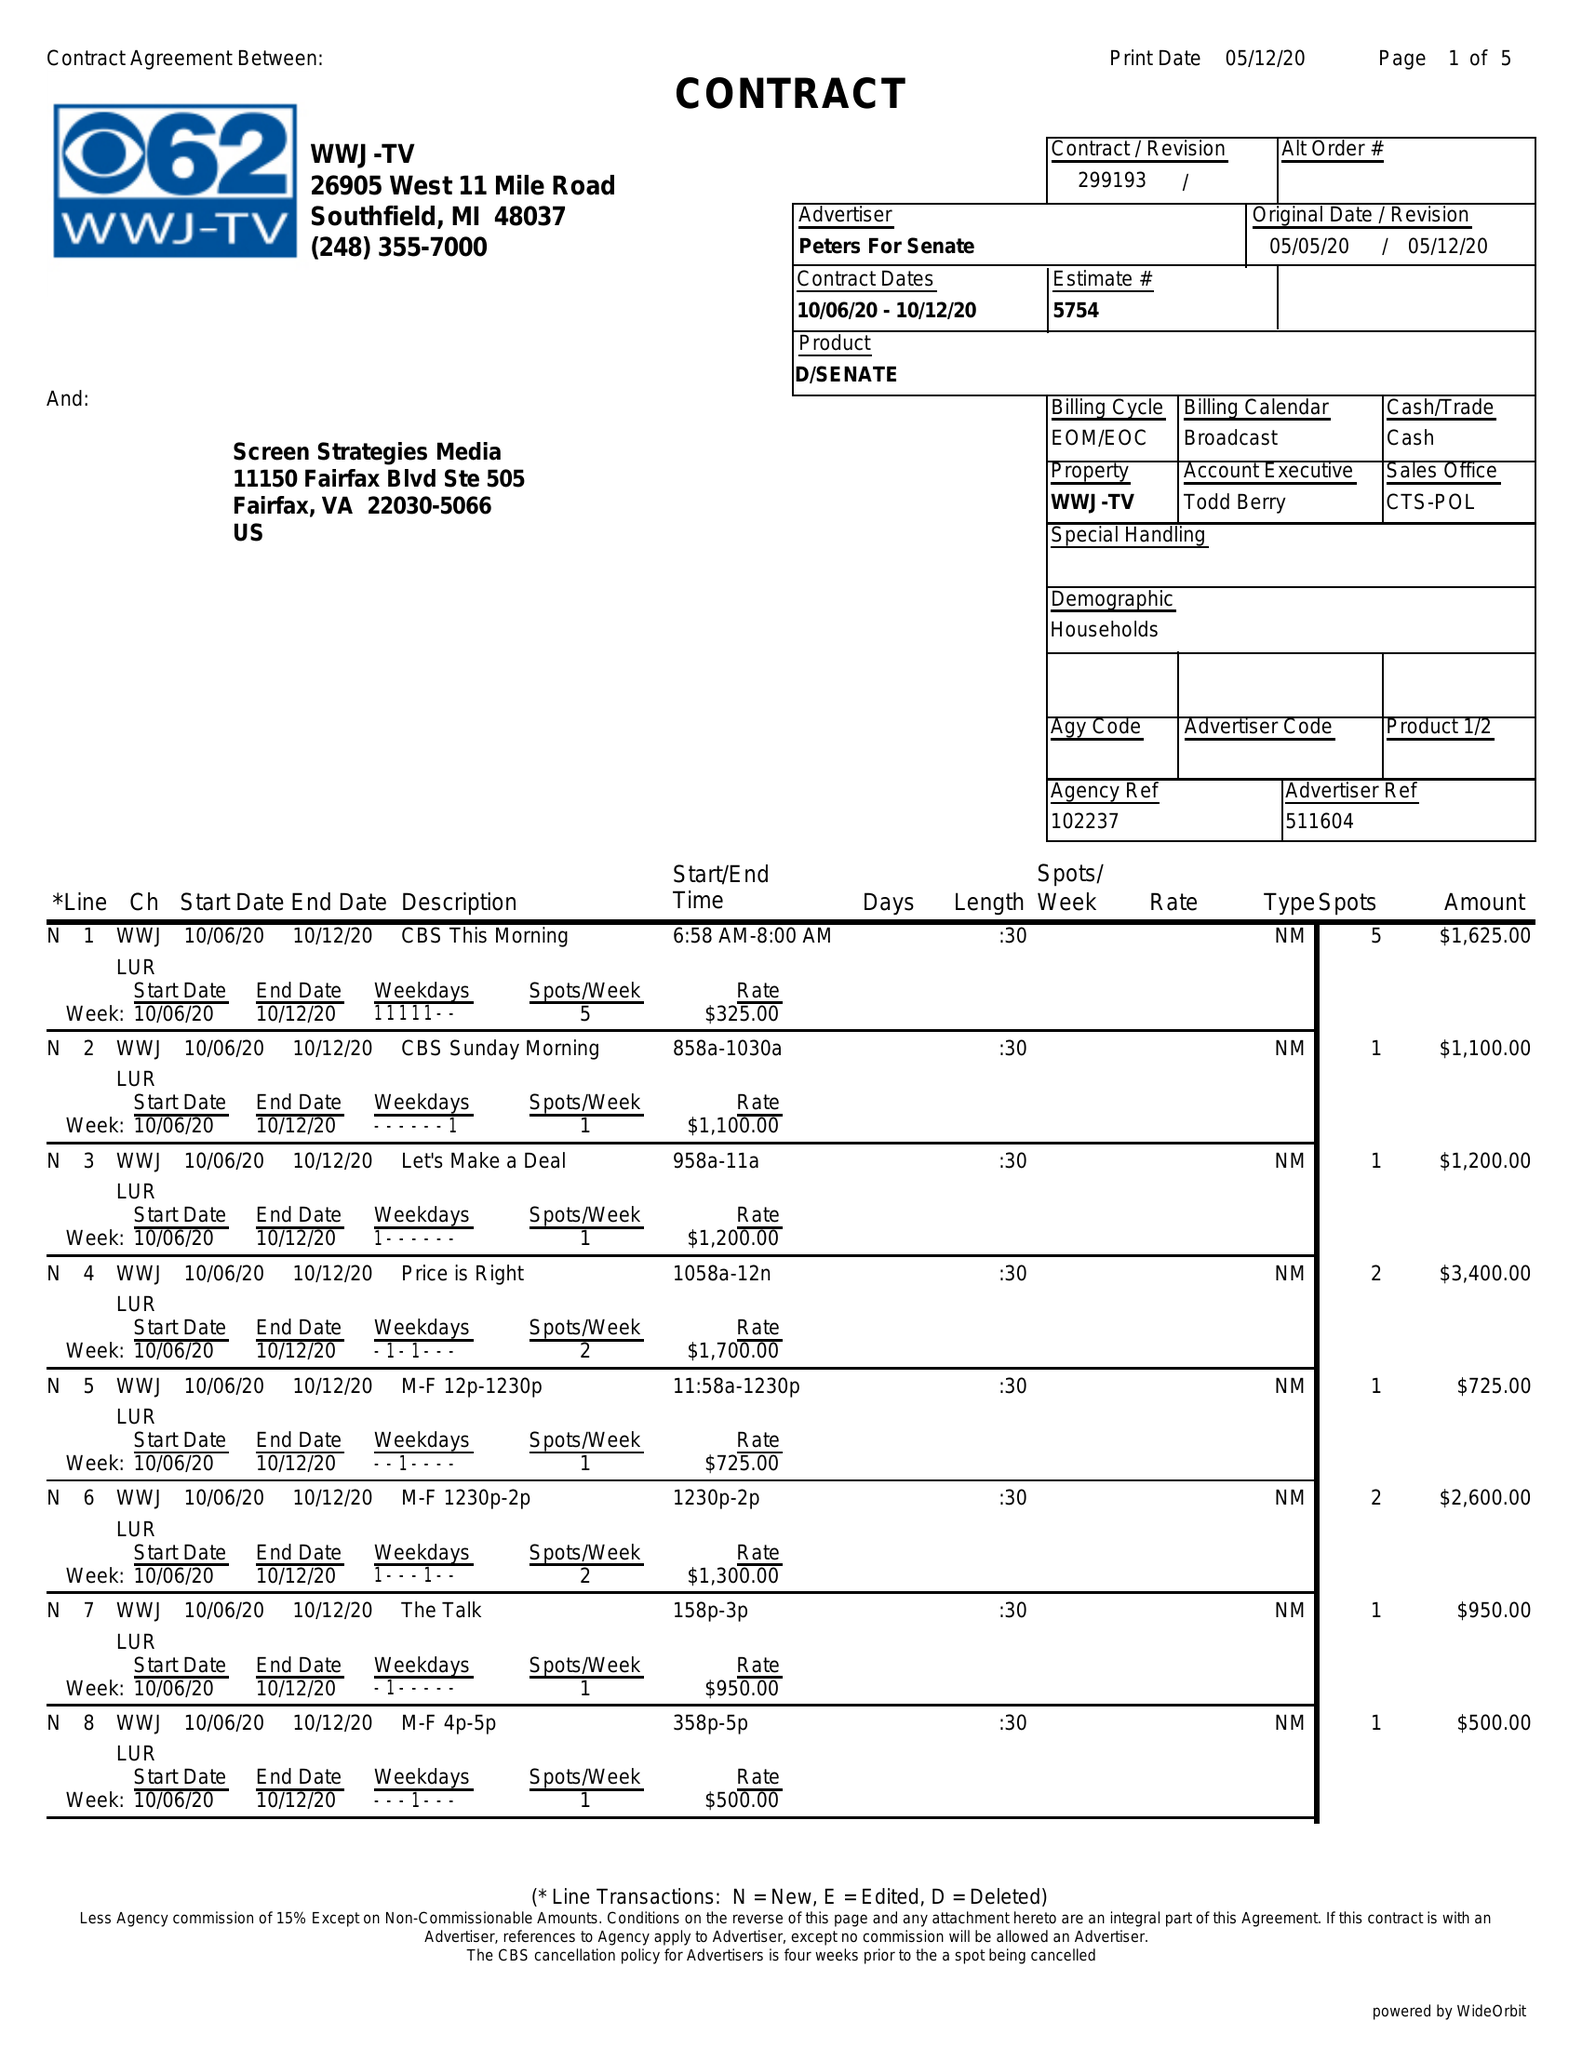What is the value for the advertiser?
Answer the question using a single word or phrase. PETERS FOR SENATE 